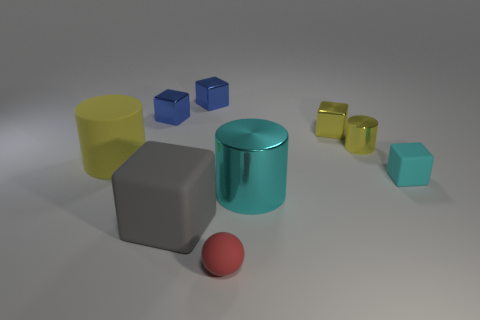Subtract all shiny cylinders. How many cylinders are left? 1 Subtract all cyan cylinders. How many cylinders are left? 2 Subtract 5 blocks. How many blocks are left? 0 Subtract all blocks. How many objects are left? 4 Subtract all blue cubes. Subtract all yellow spheres. How many cubes are left? 3 Subtract all blue cubes. How many cyan cylinders are left? 1 Subtract all big gray objects. Subtract all tiny blue things. How many objects are left? 6 Add 5 gray cubes. How many gray cubes are left? 6 Add 8 large gray matte things. How many large gray matte things exist? 9 Add 1 red metal objects. How many objects exist? 10 